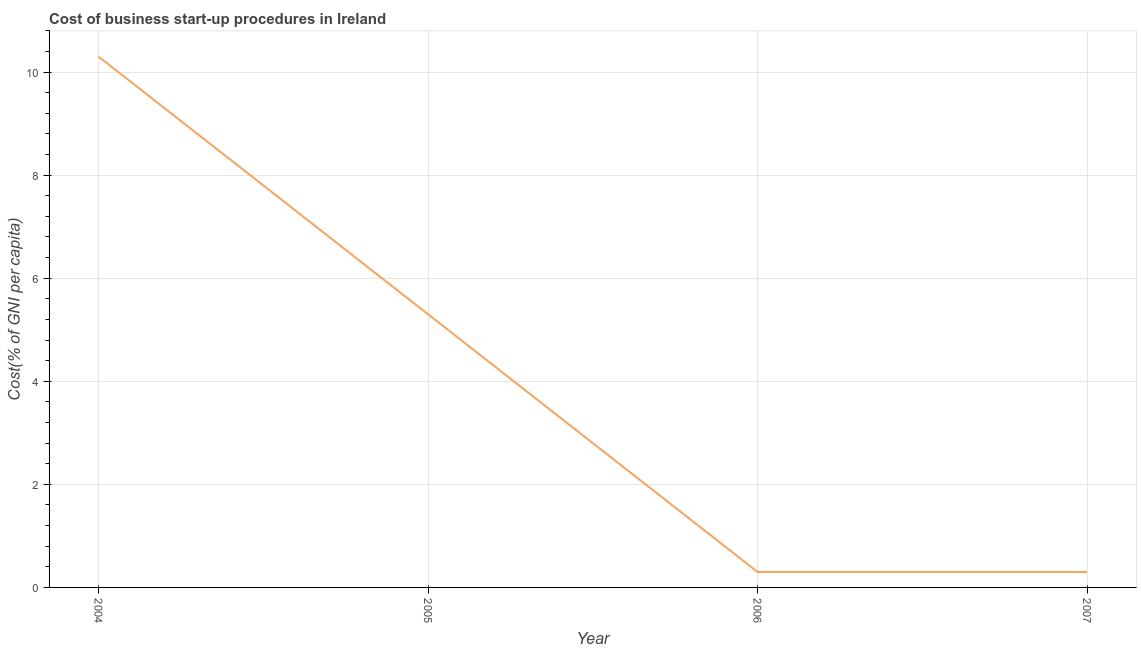What is the cost of business startup procedures in 2004?
Provide a short and direct response. 10.3. In which year was the cost of business startup procedures maximum?
Give a very brief answer. 2004. In which year was the cost of business startup procedures minimum?
Provide a succinct answer. 2006. What is the sum of the cost of business startup procedures?
Give a very brief answer. 16.2. What is the average cost of business startup procedures per year?
Keep it short and to the point. 4.05. What is the median cost of business startup procedures?
Your answer should be very brief. 2.8. Do a majority of the years between 2006 and 2005 (inclusive) have cost of business startup procedures greater than 9.2 %?
Ensure brevity in your answer.  No. What is the ratio of the cost of business startup procedures in 2005 to that in 2007?
Keep it short and to the point. 17.67. Is the difference between the cost of business startup procedures in 2005 and 2007 greater than the difference between any two years?
Ensure brevity in your answer.  No. What is the difference between the highest and the second highest cost of business startup procedures?
Offer a very short reply. 5. Is the sum of the cost of business startup procedures in 2005 and 2007 greater than the maximum cost of business startup procedures across all years?
Ensure brevity in your answer.  No. What is the difference between the highest and the lowest cost of business startup procedures?
Keep it short and to the point. 10. Does the cost of business startup procedures monotonically increase over the years?
Give a very brief answer. No. Does the graph contain grids?
Offer a terse response. Yes. What is the title of the graph?
Provide a short and direct response. Cost of business start-up procedures in Ireland. What is the label or title of the X-axis?
Provide a succinct answer. Year. What is the label or title of the Y-axis?
Provide a succinct answer. Cost(% of GNI per capita). What is the Cost(% of GNI per capita) in 2006?
Your answer should be very brief. 0.3. What is the difference between the Cost(% of GNI per capita) in 2004 and 2005?
Your answer should be very brief. 5. What is the difference between the Cost(% of GNI per capita) in 2004 and 2006?
Provide a succinct answer. 10. What is the difference between the Cost(% of GNI per capita) in 2006 and 2007?
Your answer should be very brief. 0. What is the ratio of the Cost(% of GNI per capita) in 2004 to that in 2005?
Provide a short and direct response. 1.94. What is the ratio of the Cost(% of GNI per capita) in 2004 to that in 2006?
Your answer should be compact. 34.33. What is the ratio of the Cost(% of GNI per capita) in 2004 to that in 2007?
Offer a terse response. 34.33. What is the ratio of the Cost(% of GNI per capita) in 2005 to that in 2006?
Offer a terse response. 17.67. What is the ratio of the Cost(% of GNI per capita) in 2005 to that in 2007?
Provide a short and direct response. 17.67. What is the ratio of the Cost(% of GNI per capita) in 2006 to that in 2007?
Your response must be concise. 1. 